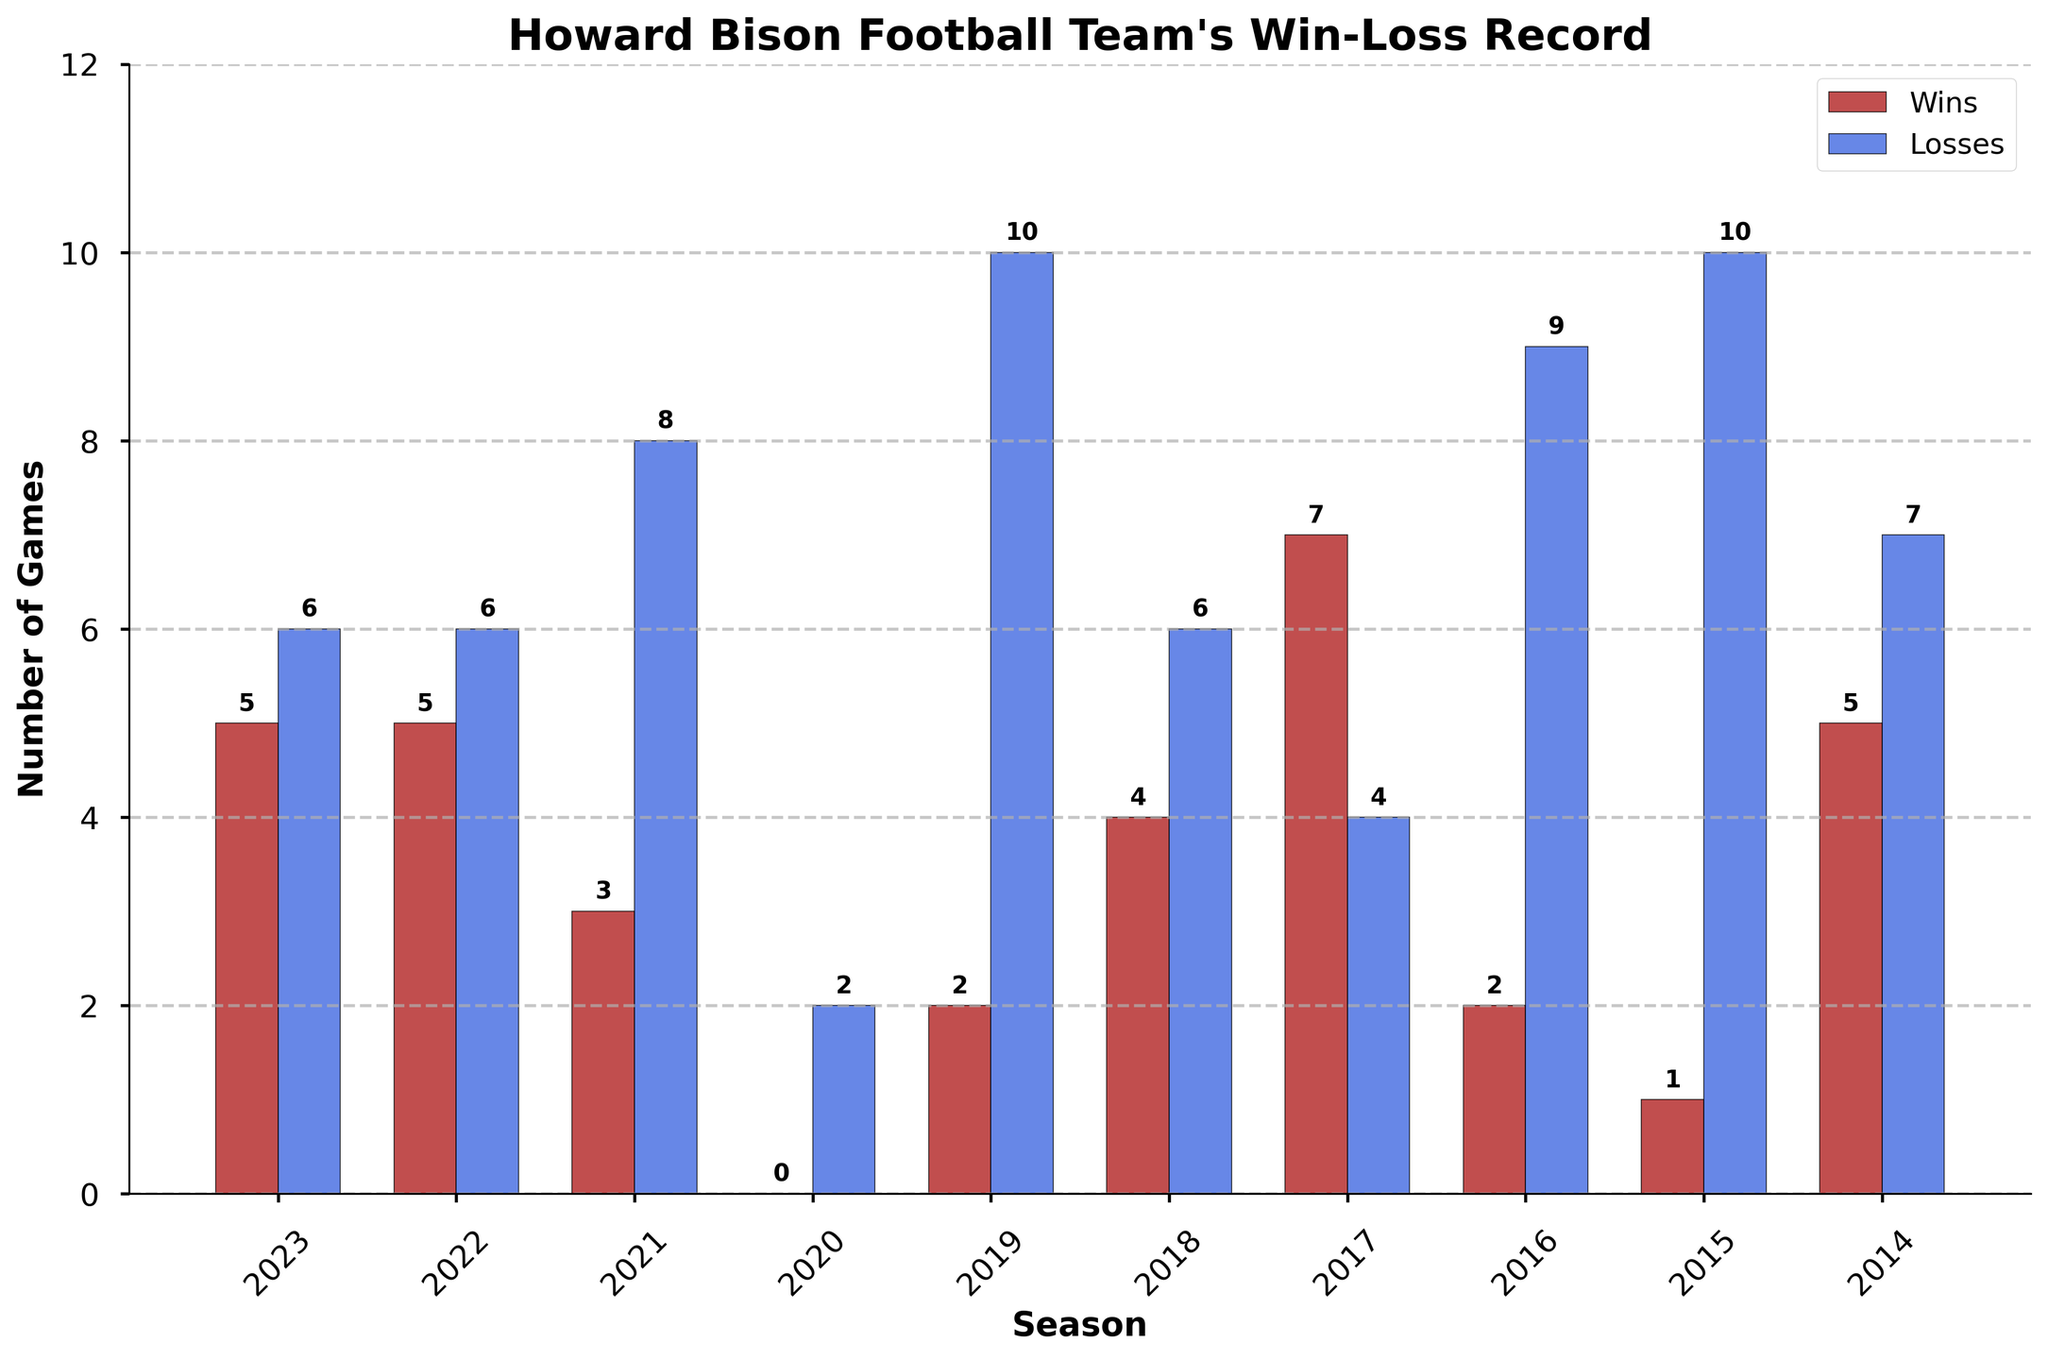Which season had the most wins? By inspecting the heights of the red bars (representing wins), the tallest bar shows the maximum number of wins. The tallest red bar is in the 2017 season with 7 wins.
Answer: 2017 Which season had the most losses? By looking at the heights of the blue bars (representing losses), the tallest blue bar shows the maximum number of losses. The tallest blue bar is in the 2019 season with 10 losses.
Answer: 2019 What is the sum of wins over the past 10 seasons? Add the number of wins for each season: 5 + 5 + 3 + 0 + 2 + 4 + 7 + 2 + 1 + 5. The sum is 34.
Answer: 34 In which seasons did the team have an equal number of wins and losses? Look for seasons where the heights of the red bars (wins) and blue bars (losses) are equal. No seasons have bars of equal height.
Answer: None What was the average number of wins over the past 10 seasons? Add up the total number of wins (34) and divide it by the number of seasons (10): 34/10 = 3.4 wins on average.
Answer: 3.4 Which season had the smallest difference between wins and losses? Calculate the difference between the wins and losses for each season and identify the smallest difference. The smallest difference is in 2023 and 2022, both with a difference of 1.
Answer: 2023 and 2022 Between which two consecutive seasons did the number of losses increase the most? Calculate the difference in the number of losses from one season to the next and identify the maximum increase. The largest increase in losses is between 2016 (9 losses) and 2017 (4 losses), a decrease of 5 losses.
Answer: 2016 and 2017 During which season did the Howard Bison football team have no wins? Identify the season with a red bar (representing wins) of height zero. The 2020 season had no wins.
Answer: 2020 In which season does the difference between wins and losses visually appear the largest? Look for the season with the greatest vertical difference between the red and blue bar heights. The 2019 season has the largest visual difference with 2 wins and 10 losses.
Answer: 2019 Which color bar is associated with losses? Based on the color legend in the figure, the blue bars represent the losses.
Answer: Blue 